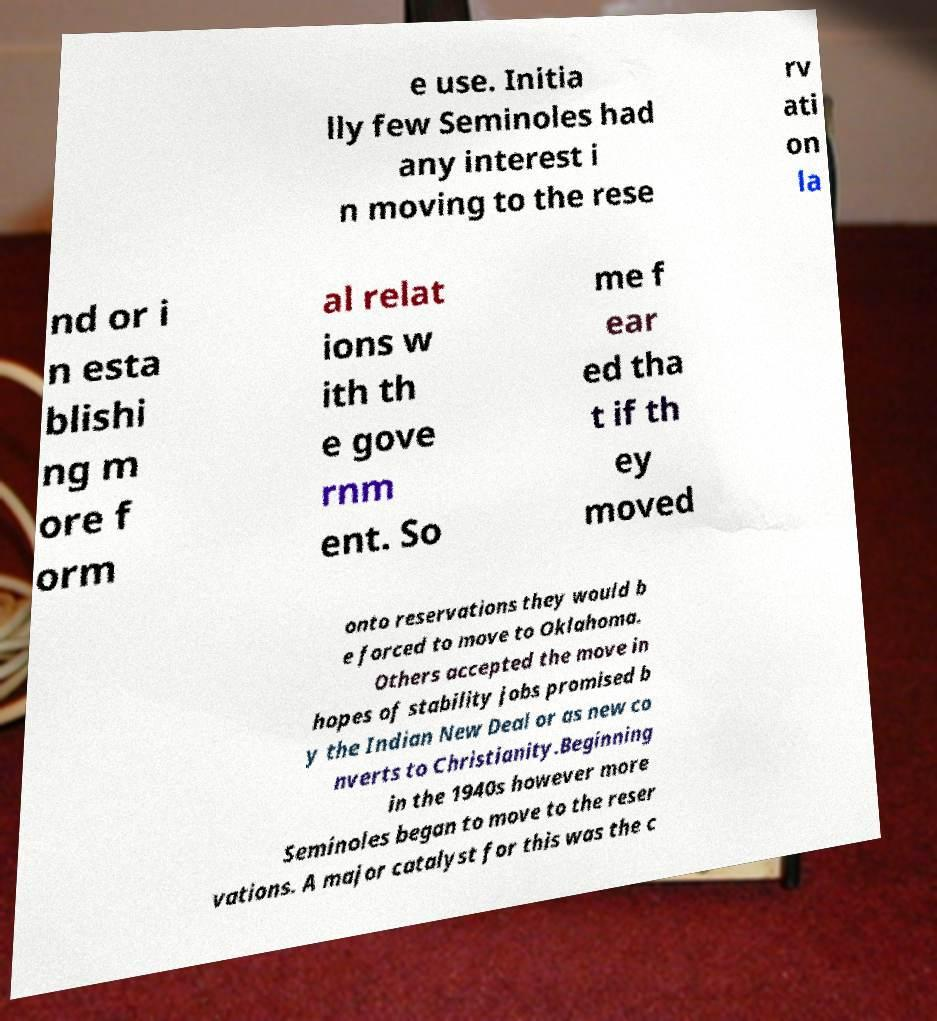Please read and relay the text visible in this image. What does it say? e use. Initia lly few Seminoles had any interest i n moving to the rese rv ati on la nd or i n esta blishi ng m ore f orm al relat ions w ith th e gove rnm ent. So me f ear ed tha t if th ey moved onto reservations they would b e forced to move to Oklahoma. Others accepted the move in hopes of stability jobs promised b y the Indian New Deal or as new co nverts to Christianity.Beginning in the 1940s however more Seminoles began to move to the reser vations. A major catalyst for this was the c 